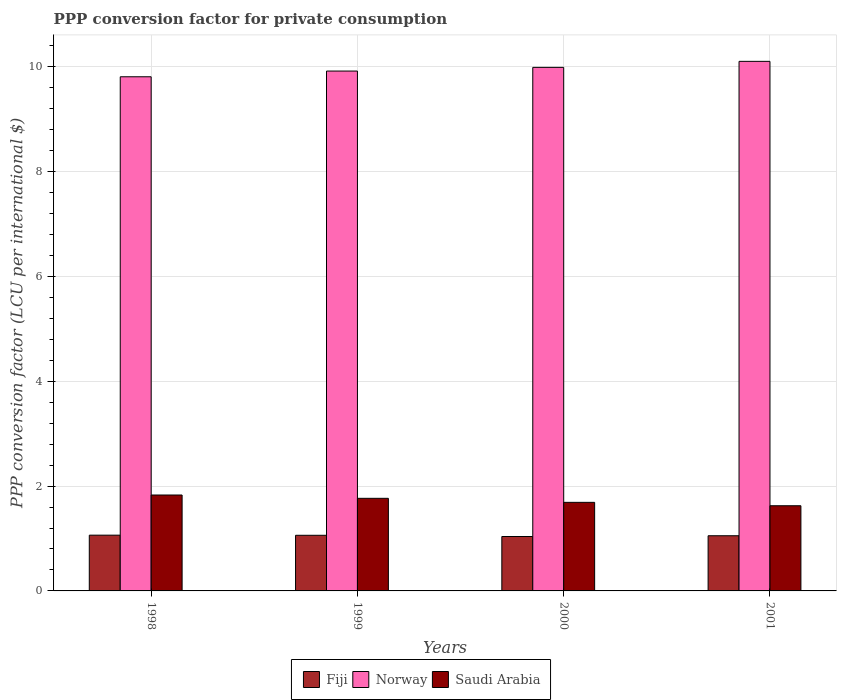How many different coloured bars are there?
Offer a very short reply. 3. How many groups of bars are there?
Provide a succinct answer. 4. What is the PPP conversion factor for private consumption in Fiji in 1999?
Provide a short and direct response. 1.06. Across all years, what is the maximum PPP conversion factor for private consumption in Norway?
Offer a terse response. 10.1. Across all years, what is the minimum PPP conversion factor for private consumption in Saudi Arabia?
Give a very brief answer. 1.63. What is the total PPP conversion factor for private consumption in Norway in the graph?
Give a very brief answer. 39.83. What is the difference between the PPP conversion factor for private consumption in Norway in 1999 and that in 2000?
Provide a succinct answer. -0.07. What is the difference between the PPP conversion factor for private consumption in Fiji in 1998 and the PPP conversion factor for private consumption in Norway in 1999?
Your response must be concise. -8.86. What is the average PPP conversion factor for private consumption in Fiji per year?
Offer a terse response. 1.05. In the year 1998, what is the difference between the PPP conversion factor for private consumption in Fiji and PPP conversion factor for private consumption in Norway?
Your answer should be very brief. -8.75. What is the ratio of the PPP conversion factor for private consumption in Saudi Arabia in 1998 to that in 1999?
Make the answer very short. 1.04. Is the PPP conversion factor for private consumption in Norway in 1998 less than that in 1999?
Ensure brevity in your answer.  Yes. Is the difference between the PPP conversion factor for private consumption in Fiji in 2000 and 2001 greater than the difference between the PPP conversion factor for private consumption in Norway in 2000 and 2001?
Provide a succinct answer. Yes. What is the difference between the highest and the second highest PPP conversion factor for private consumption in Norway?
Ensure brevity in your answer.  0.11. What is the difference between the highest and the lowest PPP conversion factor for private consumption in Fiji?
Your answer should be very brief. 0.03. In how many years, is the PPP conversion factor for private consumption in Norway greater than the average PPP conversion factor for private consumption in Norway taken over all years?
Keep it short and to the point. 2. Is the sum of the PPP conversion factor for private consumption in Saudi Arabia in 1998 and 1999 greater than the maximum PPP conversion factor for private consumption in Fiji across all years?
Your answer should be very brief. Yes. What does the 1st bar from the left in 2000 represents?
Make the answer very short. Fiji. What does the 3rd bar from the right in 2001 represents?
Your answer should be compact. Fiji. How many bars are there?
Your response must be concise. 12. Does the graph contain any zero values?
Your answer should be very brief. No. How many legend labels are there?
Ensure brevity in your answer.  3. What is the title of the graph?
Offer a very short reply. PPP conversion factor for private consumption. Does "Congo (Democratic)" appear as one of the legend labels in the graph?
Keep it short and to the point. No. What is the label or title of the Y-axis?
Your answer should be very brief. PPP conversion factor (LCU per international $). What is the PPP conversion factor (LCU per international $) of Fiji in 1998?
Provide a short and direct response. 1.06. What is the PPP conversion factor (LCU per international $) in Norway in 1998?
Offer a terse response. 9.81. What is the PPP conversion factor (LCU per international $) of Saudi Arabia in 1998?
Your answer should be compact. 1.83. What is the PPP conversion factor (LCU per international $) in Fiji in 1999?
Provide a succinct answer. 1.06. What is the PPP conversion factor (LCU per international $) in Norway in 1999?
Provide a succinct answer. 9.92. What is the PPP conversion factor (LCU per international $) in Saudi Arabia in 1999?
Your answer should be compact. 1.77. What is the PPP conversion factor (LCU per international $) in Fiji in 2000?
Give a very brief answer. 1.04. What is the PPP conversion factor (LCU per international $) in Norway in 2000?
Give a very brief answer. 9.99. What is the PPP conversion factor (LCU per international $) in Saudi Arabia in 2000?
Give a very brief answer. 1.69. What is the PPP conversion factor (LCU per international $) in Fiji in 2001?
Your response must be concise. 1.05. What is the PPP conversion factor (LCU per international $) of Norway in 2001?
Your response must be concise. 10.1. What is the PPP conversion factor (LCU per international $) of Saudi Arabia in 2001?
Keep it short and to the point. 1.63. Across all years, what is the maximum PPP conversion factor (LCU per international $) of Fiji?
Keep it short and to the point. 1.06. Across all years, what is the maximum PPP conversion factor (LCU per international $) in Norway?
Provide a succinct answer. 10.1. Across all years, what is the maximum PPP conversion factor (LCU per international $) in Saudi Arabia?
Make the answer very short. 1.83. Across all years, what is the minimum PPP conversion factor (LCU per international $) of Fiji?
Your response must be concise. 1.04. Across all years, what is the minimum PPP conversion factor (LCU per international $) in Norway?
Your answer should be very brief. 9.81. Across all years, what is the minimum PPP conversion factor (LCU per international $) of Saudi Arabia?
Ensure brevity in your answer.  1.63. What is the total PPP conversion factor (LCU per international $) of Fiji in the graph?
Provide a succinct answer. 4.22. What is the total PPP conversion factor (LCU per international $) of Norway in the graph?
Provide a short and direct response. 39.83. What is the total PPP conversion factor (LCU per international $) in Saudi Arabia in the graph?
Give a very brief answer. 6.91. What is the difference between the PPP conversion factor (LCU per international $) in Fiji in 1998 and that in 1999?
Your answer should be compact. 0. What is the difference between the PPP conversion factor (LCU per international $) in Norway in 1998 and that in 1999?
Offer a very short reply. -0.11. What is the difference between the PPP conversion factor (LCU per international $) in Saudi Arabia in 1998 and that in 1999?
Provide a succinct answer. 0.06. What is the difference between the PPP conversion factor (LCU per international $) in Fiji in 1998 and that in 2000?
Your response must be concise. 0.03. What is the difference between the PPP conversion factor (LCU per international $) in Norway in 1998 and that in 2000?
Offer a very short reply. -0.18. What is the difference between the PPP conversion factor (LCU per international $) of Saudi Arabia in 1998 and that in 2000?
Your answer should be compact. 0.14. What is the difference between the PPP conversion factor (LCU per international $) in Fiji in 1998 and that in 2001?
Offer a very short reply. 0.01. What is the difference between the PPP conversion factor (LCU per international $) in Norway in 1998 and that in 2001?
Keep it short and to the point. -0.29. What is the difference between the PPP conversion factor (LCU per international $) of Saudi Arabia in 1998 and that in 2001?
Your answer should be very brief. 0.2. What is the difference between the PPP conversion factor (LCU per international $) of Fiji in 1999 and that in 2000?
Provide a succinct answer. 0.02. What is the difference between the PPP conversion factor (LCU per international $) in Norway in 1999 and that in 2000?
Your answer should be compact. -0.07. What is the difference between the PPP conversion factor (LCU per international $) of Saudi Arabia in 1999 and that in 2000?
Offer a very short reply. 0.08. What is the difference between the PPP conversion factor (LCU per international $) in Fiji in 1999 and that in 2001?
Make the answer very short. 0.01. What is the difference between the PPP conversion factor (LCU per international $) in Norway in 1999 and that in 2001?
Offer a very short reply. -0.19. What is the difference between the PPP conversion factor (LCU per international $) of Saudi Arabia in 1999 and that in 2001?
Keep it short and to the point. 0.14. What is the difference between the PPP conversion factor (LCU per international $) of Fiji in 2000 and that in 2001?
Your answer should be compact. -0.01. What is the difference between the PPP conversion factor (LCU per international $) in Norway in 2000 and that in 2001?
Keep it short and to the point. -0.11. What is the difference between the PPP conversion factor (LCU per international $) of Saudi Arabia in 2000 and that in 2001?
Keep it short and to the point. 0.06. What is the difference between the PPP conversion factor (LCU per international $) of Fiji in 1998 and the PPP conversion factor (LCU per international $) of Norway in 1999?
Your response must be concise. -8.86. What is the difference between the PPP conversion factor (LCU per international $) in Fiji in 1998 and the PPP conversion factor (LCU per international $) in Saudi Arabia in 1999?
Your response must be concise. -0.7. What is the difference between the PPP conversion factor (LCU per international $) of Norway in 1998 and the PPP conversion factor (LCU per international $) of Saudi Arabia in 1999?
Your answer should be compact. 8.04. What is the difference between the PPP conversion factor (LCU per international $) of Fiji in 1998 and the PPP conversion factor (LCU per international $) of Norway in 2000?
Offer a very short reply. -8.93. What is the difference between the PPP conversion factor (LCU per international $) in Fiji in 1998 and the PPP conversion factor (LCU per international $) in Saudi Arabia in 2000?
Your answer should be very brief. -0.63. What is the difference between the PPP conversion factor (LCU per international $) of Norway in 1998 and the PPP conversion factor (LCU per international $) of Saudi Arabia in 2000?
Your response must be concise. 8.12. What is the difference between the PPP conversion factor (LCU per international $) of Fiji in 1998 and the PPP conversion factor (LCU per international $) of Norway in 2001?
Provide a succinct answer. -9.04. What is the difference between the PPP conversion factor (LCU per international $) in Fiji in 1998 and the PPP conversion factor (LCU per international $) in Saudi Arabia in 2001?
Make the answer very short. -0.56. What is the difference between the PPP conversion factor (LCU per international $) of Norway in 1998 and the PPP conversion factor (LCU per international $) of Saudi Arabia in 2001?
Provide a short and direct response. 8.19. What is the difference between the PPP conversion factor (LCU per international $) in Fiji in 1999 and the PPP conversion factor (LCU per international $) in Norway in 2000?
Keep it short and to the point. -8.93. What is the difference between the PPP conversion factor (LCU per international $) of Fiji in 1999 and the PPP conversion factor (LCU per international $) of Saudi Arabia in 2000?
Offer a terse response. -0.63. What is the difference between the PPP conversion factor (LCU per international $) of Norway in 1999 and the PPP conversion factor (LCU per international $) of Saudi Arabia in 2000?
Your answer should be compact. 8.23. What is the difference between the PPP conversion factor (LCU per international $) in Fiji in 1999 and the PPP conversion factor (LCU per international $) in Norway in 2001?
Your response must be concise. -9.04. What is the difference between the PPP conversion factor (LCU per international $) in Fiji in 1999 and the PPP conversion factor (LCU per international $) in Saudi Arabia in 2001?
Offer a terse response. -0.56. What is the difference between the PPP conversion factor (LCU per international $) of Norway in 1999 and the PPP conversion factor (LCU per international $) of Saudi Arabia in 2001?
Provide a succinct answer. 8.29. What is the difference between the PPP conversion factor (LCU per international $) of Fiji in 2000 and the PPP conversion factor (LCU per international $) of Norway in 2001?
Offer a very short reply. -9.07. What is the difference between the PPP conversion factor (LCU per international $) in Fiji in 2000 and the PPP conversion factor (LCU per international $) in Saudi Arabia in 2001?
Provide a short and direct response. -0.59. What is the difference between the PPP conversion factor (LCU per international $) of Norway in 2000 and the PPP conversion factor (LCU per international $) of Saudi Arabia in 2001?
Provide a short and direct response. 8.36. What is the average PPP conversion factor (LCU per international $) of Fiji per year?
Provide a short and direct response. 1.05. What is the average PPP conversion factor (LCU per international $) of Norway per year?
Your answer should be very brief. 9.96. What is the average PPP conversion factor (LCU per international $) of Saudi Arabia per year?
Provide a succinct answer. 1.73. In the year 1998, what is the difference between the PPP conversion factor (LCU per international $) of Fiji and PPP conversion factor (LCU per international $) of Norway?
Ensure brevity in your answer.  -8.75. In the year 1998, what is the difference between the PPP conversion factor (LCU per international $) of Fiji and PPP conversion factor (LCU per international $) of Saudi Arabia?
Provide a succinct answer. -0.77. In the year 1998, what is the difference between the PPP conversion factor (LCU per international $) in Norway and PPP conversion factor (LCU per international $) in Saudi Arabia?
Your answer should be compact. 7.98. In the year 1999, what is the difference between the PPP conversion factor (LCU per international $) of Fiji and PPP conversion factor (LCU per international $) of Norway?
Give a very brief answer. -8.86. In the year 1999, what is the difference between the PPP conversion factor (LCU per international $) in Fiji and PPP conversion factor (LCU per international $) in Saudi Arabia?
Provide a short and direct response. -0.71. In the year 1999, what is the difference between the PPP conversion factor (LCU per international $) in Norway and PPP conversion factor (LCU per international $) in Saudi Arabia?
Offer a very short reply. 8.15. In the year 2000, what is the difference between the PPP conversion factor (LCU per international $) in Fiji and PPP conversion factor (LCU per international $) in Norway?
Make the answer very short. -8.95. In the year 2000, what is the difference between the PPP conversion factor (LCU per international $) in Fiji and PPP conversion factor (LCU per international $) in Saudi Arabia?
Keep it short and to the point. -0.65. In the year 2000, what is the difference between the PPP conversion factor (LCU per international $) in Norway and PPP conversion factor (LCU per international $) in Saudi Arabia?
Keep it short and to the point. 8.3. In the year 2001, what is the difference between the PPP conversion factor (LCU per international $) of Fiji and PPP conversion factor (LCU per international $) of Norway?
Provide a succinct answer. -9.05. In the year 2001, what is the difference between the PPP conversion factor (LCU per international $) of Fiji and PPP conversion factor (LCU per international $) of Saudi Arabia?
Keep it short and to the point. -0.57. In the year 2001, what is the difference between the PPP conversion factor (LCU per international $) in Norway and PPP conversion factor (LCU per international $) in Saudi Arabia?
Keep it short and to the point. 8.48. What is the ratio of the PPP conversion factor (LCU per international $) in Fiji in 1998 to that in 1999?
Your response must be concise. 1. What is the ratio of the PPP conversion factor (LCU per international $) in Saudi Arabia in 1998 to that in 1999?
Make the answer very short. 1.04. What is the ratio of the PPP conversion factor (LCU per international $) of Fiji in 1998 to that in 2000?
Offer a very short reply. 1.02. What is the ratio of the PPP conversion factor (LCU per international $) of Norway in 1998 to that in 2000?
Ensure brevity in your answer.  0.98. What is the ratio of the PPP conversion factor (LCU per international $) of Saudi Arabia in 1998 to that in 2000?
Make the answer very short. 1.08. What is the ratio of the PPP conversion factor (LCU per international $) in Fiji in 1998 to that in 2001?
Ensure brevity in your answer.  1.01. What is the ratio of the PPP conversion factor (LCU per international $) in Norway in 1998 to that in 2001?
Ensure brevity in your answer.  0.97. What is the ratio of the PPP conversion factor (LCU per international $) in Saudi Arabia in 1998 to that in 2001?
Your answer should be very brief. 1.13. What is the ratio of the PPP conversion factor (LCU per international $) in Fiji in 1999 to that in 2000?
Your response must be concise. 1.02. What is the ratio of the PPP conversion factor (LCU per international $) of Norway in 1999 to that in 2000?
Give a very brief answer. 0.99. What is the ratio of the PPP conversion factor (LCU per international $) of Saudi Arabia in 1999 to that in 2000?
Your answer should be very brief. 1.05. What is the ratio of the PPP conversion factor (LCU per international $) of Fiji in 1999 to that in 2001?
Give a very brief answer. 1.01. What is the ratio of the PPP conversion factor (LCU per international $) of Norway in 1999 to that in 2001?
Your answer should be compact. 0.98. What is the ratio of the PPP conversion factor (LCU per international $) in Saudi Arabia in 1999 to that in 2001?
Keep it short and to the point. 1.09. What is the ratio of the PPP conversion factor (LCU per international $) of Fiji in 2000 to that in 2001?
Provide a short and direct response. 0.99. What is the ratio of the PPP conversion factor (LCU per international $) in Norway in 2000 to that in 2001?
Offer a terse response. 0.99. What is the ratio of the PPP conversion factor (LCU per international $) of Saudi Arabia in 2000 to that in 2001?
Provide a short and direct response. 1.04. What is the difference between the highest and the second highest PPP conversion factor (LCU per international $) of Fiji?
Make the answer very short. 0. What is the difference between the highest and the second highest PPP conversion factor (LCU per international $) in Norway?
Provide a short and direct response. 0.11. What is the difference between the highest and the second highest PPP conversion factor (LCU per international $) of Saudi Arabia?
Provide a short and direct response. 0.06. What is the difference between the highest and the lowest PPP conversion factor (LCU per international $) in Fiji?
Offer a very short reply. 0.03. What is the difference between the highest and the lowest PPP conversion factor (LCU per international $) of Norway?
Ensure brevity in your answer.  0.29. What is the difference between the highest and the lowest PPP conversion factor (LCU per international $) of Saudi Arabia?
Offer a terse response. 0.2. 